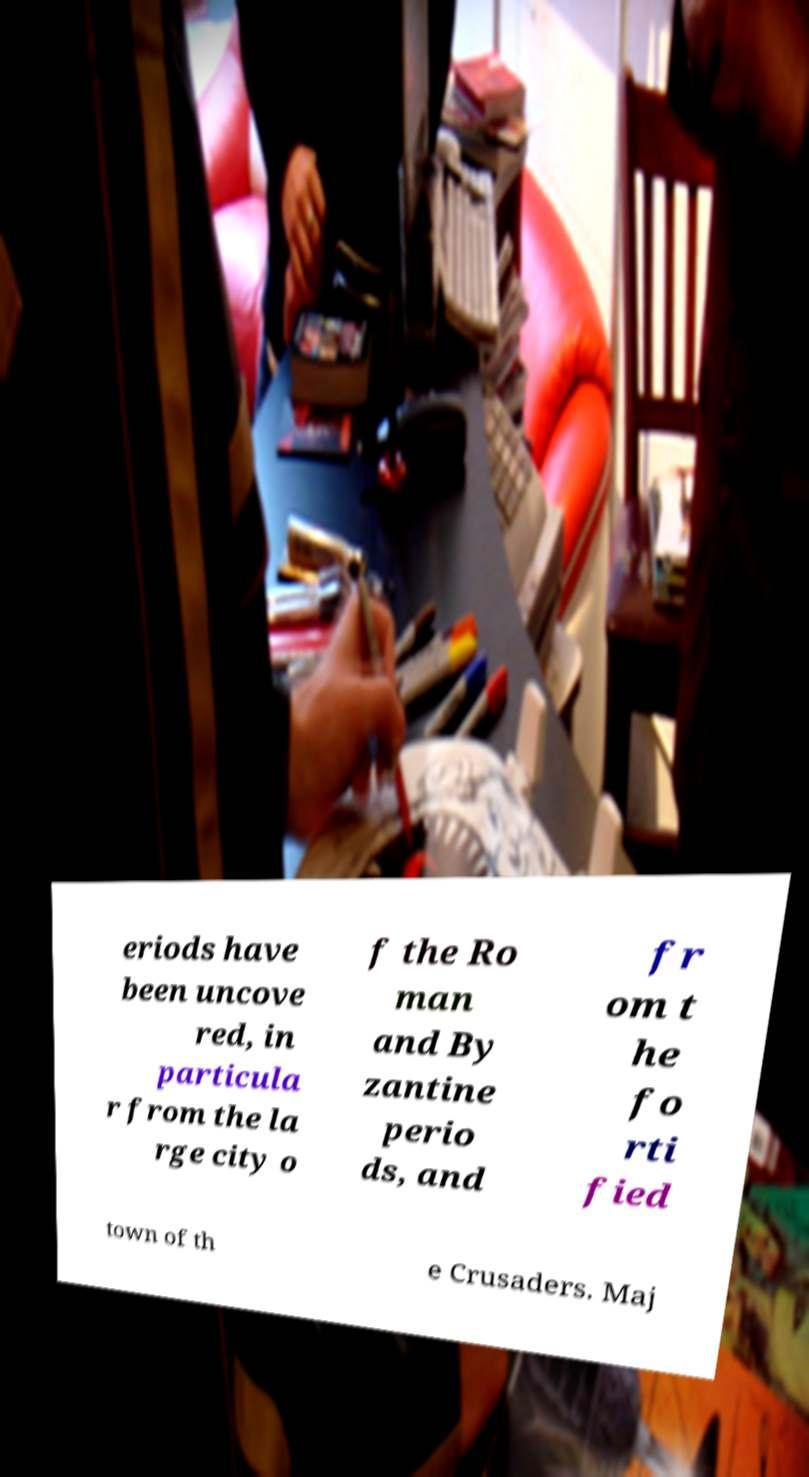Could you extract and type out the text from this image? eriods have been uncove red, in particula r from the la rge city o f the Ro man and By zantine perio ds, and fr om t he fo rti fied town of th e Crusaders. Maj 